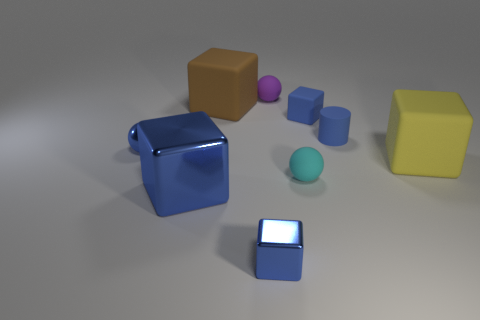Subtract all blue blocks. How many were subtracted if there are1blue blocks left? 2 Subtract all matte balls. How many balls are left? 1 Subtract all blue blocks. How many blocks are left? 2 Subtract all balls. How many objects are left? 6 Subtract 1 balls. How many balls are left? 2 Subtract all brown cubes. How many purple spheres are left? 1 Subtract all small purple things. Subtract all tiny purple rubber balls. How many objects are left? 7 Add 1 big blocks. How many big blocks are left? 4 Add 7 green rubber cylinders. How many green rubber cylinders exist? 7 Subtract 0 purple cubes. How many objects are left? 9 